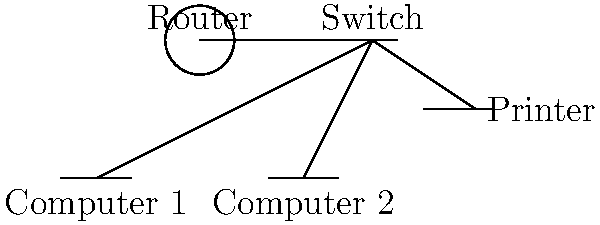In a typical office network setup, which component acts as the central point for connecting multiple devices and facilitating communication between them? How does this component contribute to the efficiency of information flow within the corporate environment? To answer this question, let's break down the components of a typical office network setup and their functions:

1. Router: Connects the office network to the external internet and manages data traffic between the internal network and the outside world.

2. Switch: Acts as the central connection point for all devices within the office network. It receives data packets and directs them to their intended destinations within the local network.

3. Computers: End-user devices that connect to the network for data access and communication.

4. Printer: A shared resource connected to the network for multiple users to access.

The switch is the key component that acts as the central point for connecting multiple devices. Here's how it contributes to the efficiency of information flow:

1. Centralized connectivity: The switch allows all devices to connect to a single point, simplifying network management and reducing cable clutter.

2. Intelligent data routing: It uses MAC addresses to direct data packets only to the intended recipient, reducing network congestion and improving overall performance.

3. Scalability: Switches can easily accommodate additional devices as the office grows, making network expansion simpler.

4. Segmentation: Some switches can create virtual LANs (VLANs) to logically separate different departments or functions within the office, enhancing security and performance.

5. Resource sharing: By connecting all devices, the switch enables easy sharing of resources like printers and file servers across the office.

In the corporate communications context, understanding the role of the switch helps in explaining how information flows efficiently within the organization, supporting the argument for using specific networking terminology when discussing office infrastructure and data management strategies.
Answer: Switch 